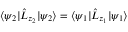Convert formula to latex. <formula><loc_0><loc_0><loc_500><loc_500>\langle \psi _ { 2 } | \hat { L } _ { z _ { 2 } } | \psi _ { 2 } \rangle = \langle \psi _ { 1 } | \hat { L } _ { z _ { 1 } } | \psi _ { 1 } \rangle</formula> 